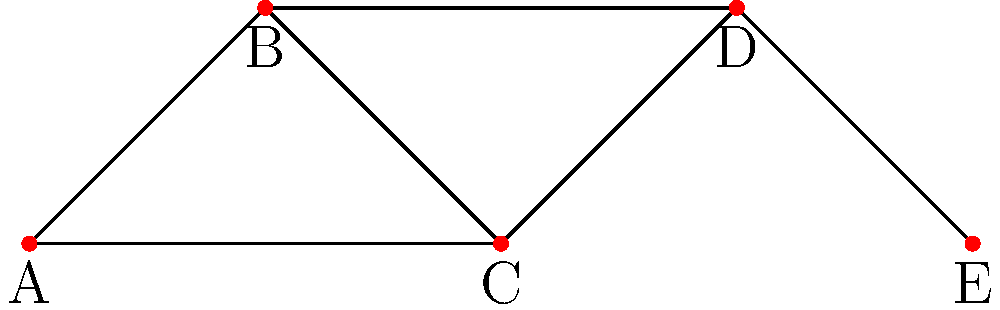In the political network graph shown above, each node represents a politician, and edges represent alliances. What is the minimum number of alliances that need to be broken to completely isolate politician C from all other politicians? To answer this question, we need to analyze the connectivity of node C in the graph:

1. Identify the connections of node C:
   - C is directly connected to B and D.
   - C is also connected to A through the edge A-C.

2. Count the number of edges that need to be removed to isolate C:
   - We need to remove the edge B-C
   - We need to remove the edge C-D
   - We need to remove the edge A-C

3. Verify that removing these three edges will completely isolate C:
   - After removing these edges, C will have no direct connections to any other node in the graph.

4. Check if there's a more efficient way to isolate C:
   - There is no way to isolate C by removing fewer than 3 edges, as each edge must be removed to cut all paths to C.

Therefore, the minimum number of alliances that need to be broken to completely isolate politician C is 3.
Answer: 3 